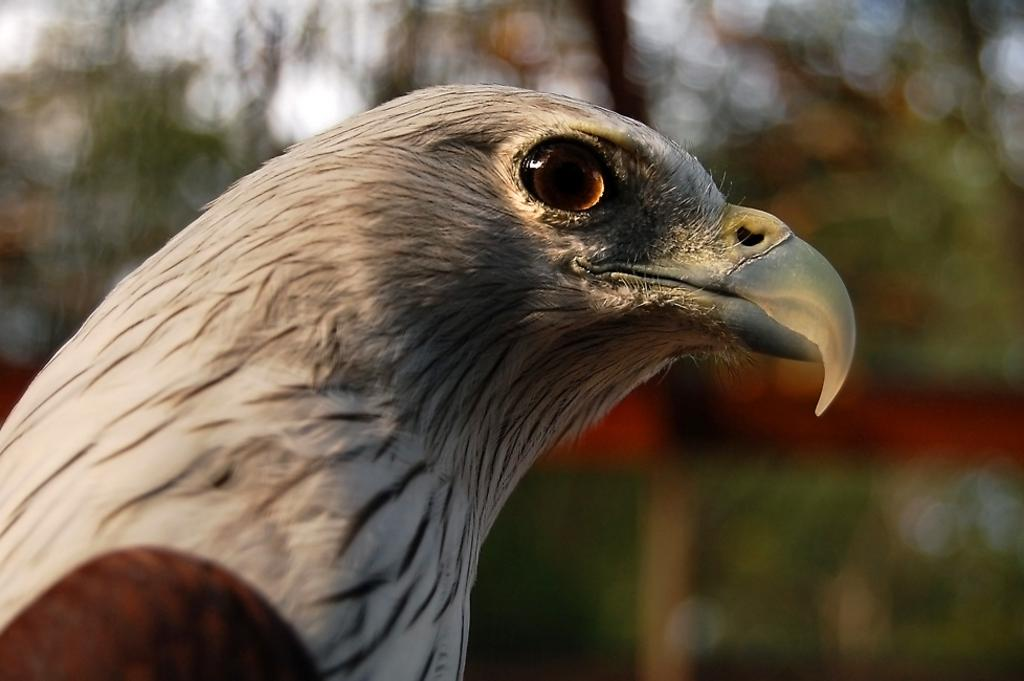What type of animal is in the image? There is a bird in the image. Can you describe the bird's coloring? The bird has white and brown coloring. What can be observed about the background of the image? The background of the image is blurred. What achievement did the bird accomplish in the image? There is no indication of any achievements in the image; it simply shows a bird with white and brown coloring against a blurred background. 